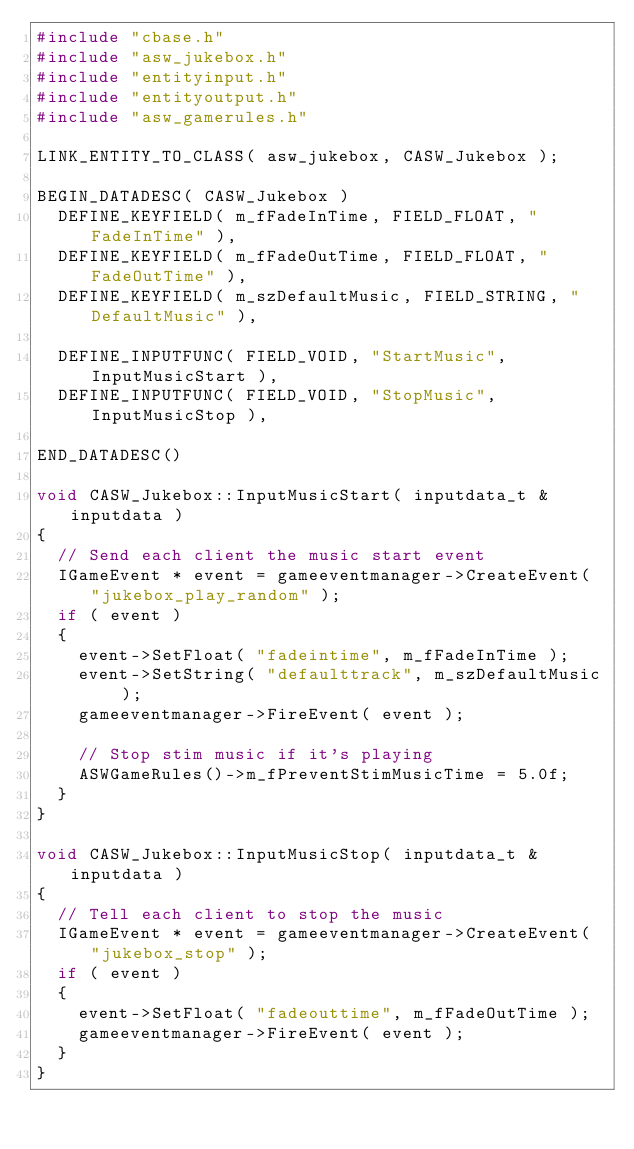Convert code to text. <code><loc_0><loc_0><loc_500><loc_500><_C++_>#include "cbase.h"
#include "asw_jukebox.h"
#include "entityinput.h"
#include "entityoutput.h"
#include "asw_gamerules.h"

LINK_ENTITY_TO_CLASS( asw_jukebox, CASW_Jukebox );

BEGIN_DATADESC( CASW_Jukebox )
	DEFINE_KEYFIELD( m_fFadeInTime, FIELD_FLOAT, "FadeInTime" ),
	DEFINE_KEYFIELD( m_fFadeOutTime, FIELD_FLOAT, "FadeOutTime" ),
	DEFINE_KEYFIELD( m_szDefaultMusic, FIELD_STRING, "DefaultMusic" ),

	DEFINE_INPUTFUNC( FIELD_VOID, "StartMusic", InputMusicStart ),
	DEFINE_INPUTFUNC( FIELD_VOID, "StopMusic", InputMusicStop ),

END_DATADESC()

void CASW_Jukebox::InputMusicStart( inputdata_t &inputdata )
{
	// Send each client the music start event
	IGameEvent * event = gameeventmanager->CreateEvent( "jukebox_play_random" );
	if ( event )
	{
		event->SetFloat( "fadeintime", m_fFadeInTime );
		event->SetString( "defaulttrack", m_szDefaultMusic );
		gameeventmanager->FireEvent( event );

		// Stop stim music if it's playing
		ASWGameRules()->m_fPreventStimMusicTime = 5.0f;
	}
}

void CASW_Jukebox::InputMusicStop( inputdata_t &inputdata )
{
	// Tell each client to stop the music
	IGameEvent * event = gameeventmanager->CreateEvent( "jukebox_stop" );
	if ( event )
	{
		event->SetFloat( "fadeouttime", m_fFadeOutTime );
		gameeventmanager->FireEvent( event );
	}
}</code> 